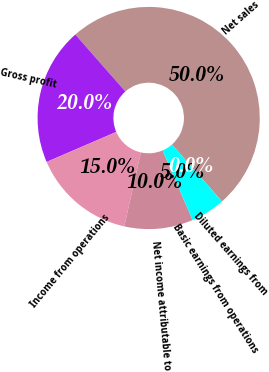<chart> <loc_0><loc_0><loc_500><loc_500><pie_chart><fcel>Net sales<fcel>Gross profit<fcel>Income from operations<fcel>Net income attributable to<fcel>Basic earnings from operations<fcel>Diluted earnings from<nl><fcel>50.0%<fcel>20.0%<fcel>15.0%<fcel>10.0%<fcel>5.0%<fcel>0.0%<nl></chart> 